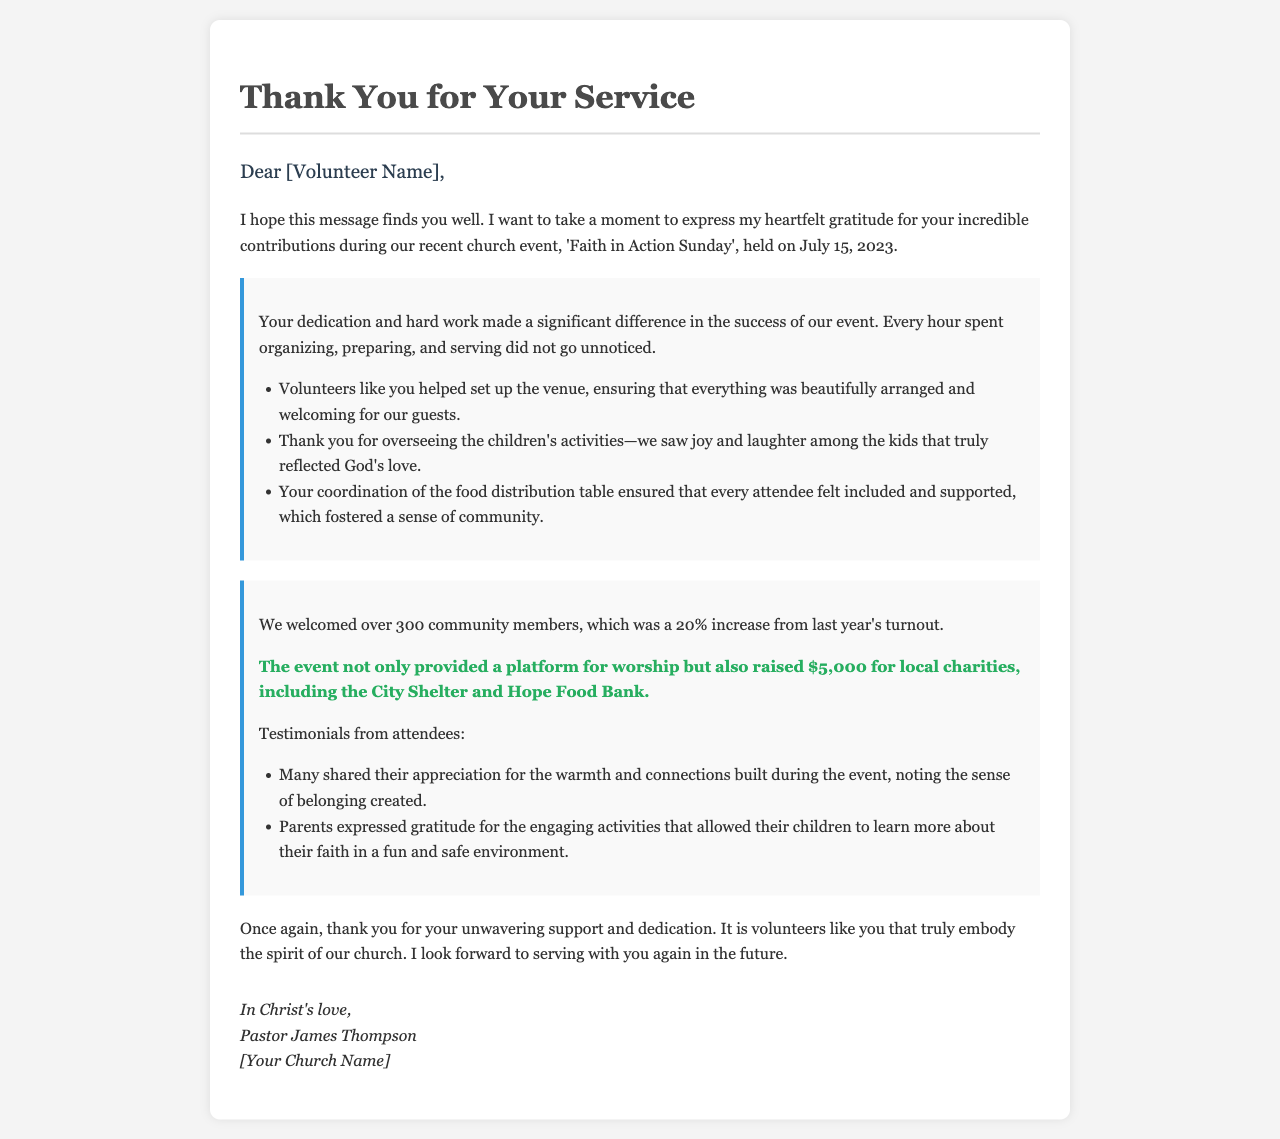What is the name of the church event? The document mentions the event as 'Faith in Action Sunday'.
Answer: Faith in Action Sunday When was the event held? The date of the event is explicitly stated in the document as July 15, 2023.
Answer: July 15, 2023 How many community members were welcomed at the event? The document states that over 300 community members attended the event.
Answer: 300 By what percentage did the turnout increase from last year? The document indicates that there was a 20% increase in turnout compared to the previous year.
Answer: 20% What was the amount raised for local charities? The document mentions that the event raised $5,000 for local charities.
Answer: $5,000 What activities were overseen by volunteers? The document highlights that volunteers oversaw children's activities, which brought joy and laughter.
Answer: Children's activities Which organizations benefited from the funds raised at the event? The document specifies that the funds went to the City Shelter and Hope Food Bank.
Answer: City Shelter and Hope Food Bank Who signed the letter? The letter is signed by Pastor James Thompson.
Answer: Pastor James Thompson What sentiment is expressed towards the volunteers in the letter? The document expresses heartfelt gratitude, indicating the volunteers made a significant difference.
Answer: Heartfelt gratitude 